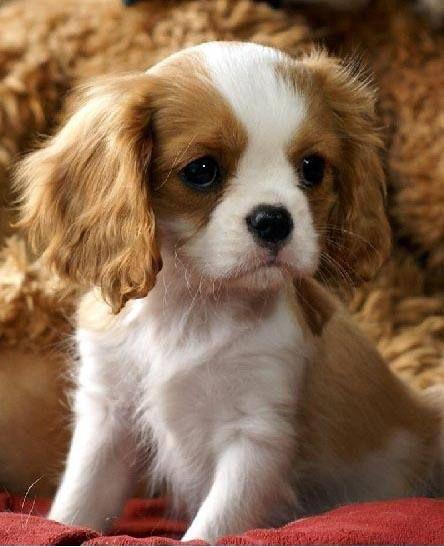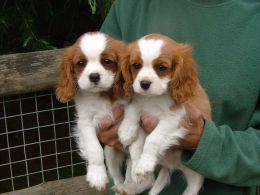The first image is the image on the left, the second image is the image on the right. Evaluate the accuracy of this statement regarding the images: "The right and left images contain the same number of puppies.". Is it true? Answer yes or no. No. 